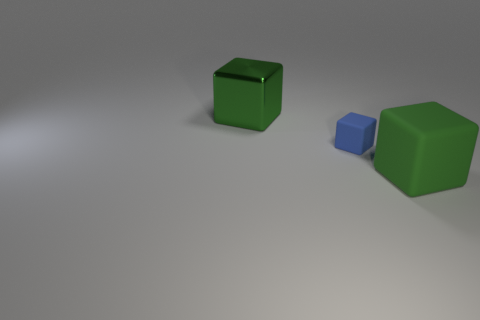Is the number of blue blocks that are right of the green matte thing the same as the number of tiny gray balls? Upon observing the image, it's clear there is only one blue block visible to the right of the green objects. However, no tiny gray balls can be observed within the frame, making a direct comparison impossible based on the image. The original answer stating 'yes' may have been a misunderstanding, as the image does not show any gray balls to substantiate that claim. 